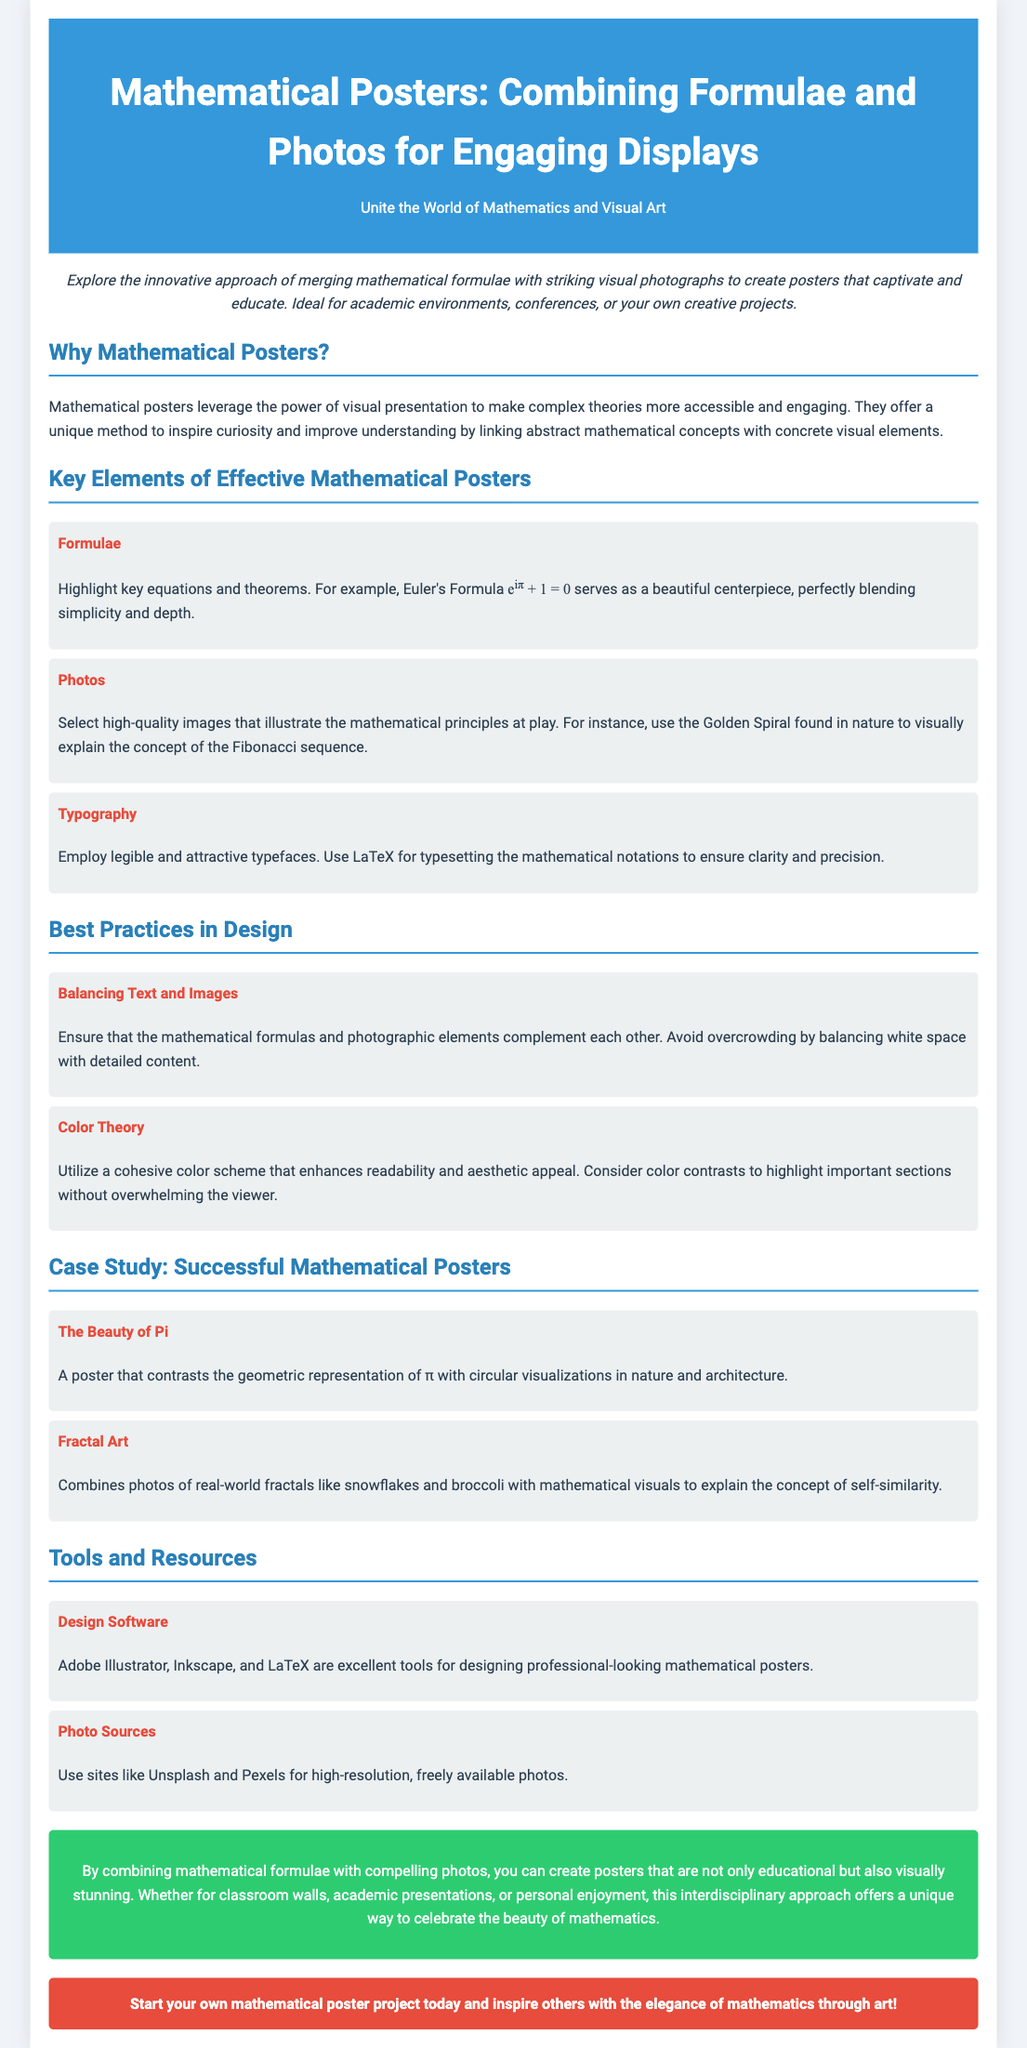What is the title of the document? The title of the document is prominently displayed in the header section.
Answer: Mathematical Posters: Combining Formulae and Photos for Engaging Displays What is Euler's Formula? Euler's Formula is highlighted as an example of a mathematical formula in the document.
Answer: e^iπ + 1 = 0 Which color is used for the conclusion section? The conclusion section is described to have a specific background color which is mentioned in the document.
Answer: Green What are two recommended design software? The document lists design software suitable for creating mathematical posters.
Answer: Adobe Illustrator, LaTeX What concept is explained using the Golden Spiral? The document explains a specific mathematical concept using the Golden Spiral.
Answer: Fibonacci sequence How should text and images be balanced according to the best practices? The document recommends a practice regarding the relationship between text and images.
Answer: Balance white space with detailed content What type of photos should be selected for mathematical posters? The document suggests a specific quality for photos to be used in posters.
Answer: High-quality images Which website is suggested for high-resolution photos? The document lists a source for freely available photos that can be used.
Answer: Unsplash What is the main purpose of combining mathematical formulae with images? The document explains the overarching goal of the described approach.
Answer: To captivate and educate 